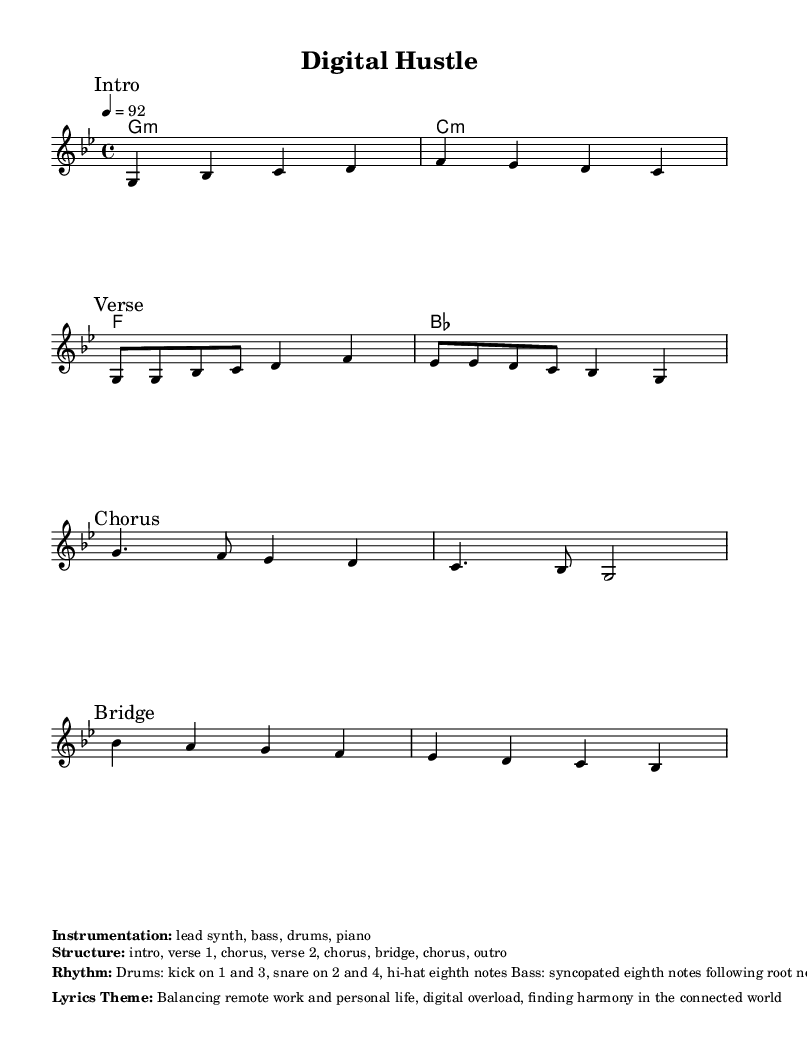What is the key signature of this music? The key signature is G minor, which consists of two flats (B♭ and E♭). This can be identified by looking at the key signature indicated at the beginning of the sheet music.
Answer: G minor What is the time signature of this music? The time signature is 4/4, meaning there are four beats in each measure and the quarter note receives one beat. This is evident from the notation at the beginning of the score.
Answer: 4/4 What is the tempo marking in the music? The tempo marking indicates a speed of 92 beats per minute, which can be found at the start, specifying the pace of the song.
Answer: 92 How many sections are included in the structure of the song? The structure includes eight sections: intro, verse 1, chorus, verse 2, chorus, bridge, chorus, and outro. This is outlined in the markup providing the song structure.
Answer: 8 What is the main theme of the lyrics? The lyrics theme focuses on balancing remote work and personal life amidst digital overload, which is specified in the lyrics theme section of the markup.
Answer: Balancing remote work and personal life What type of instruments are used in the song? The instrumentation includes lead synth, bass, drums, and piano, as stated in the instrumentation markup at the bottom of the sheet music.
Answer: lead synth, bass, drums, piano How is the rhythm structured for the drums? The rhythm for the drums consists of a kick on beats 1 and 3, a snare on beats 2 and 4, and hi-hats playing eighth notes, detailed in the rhythm section of the markup.
Answer: kick on 1 and 3, snare on 2 and 4, hi-hat eighth notes 